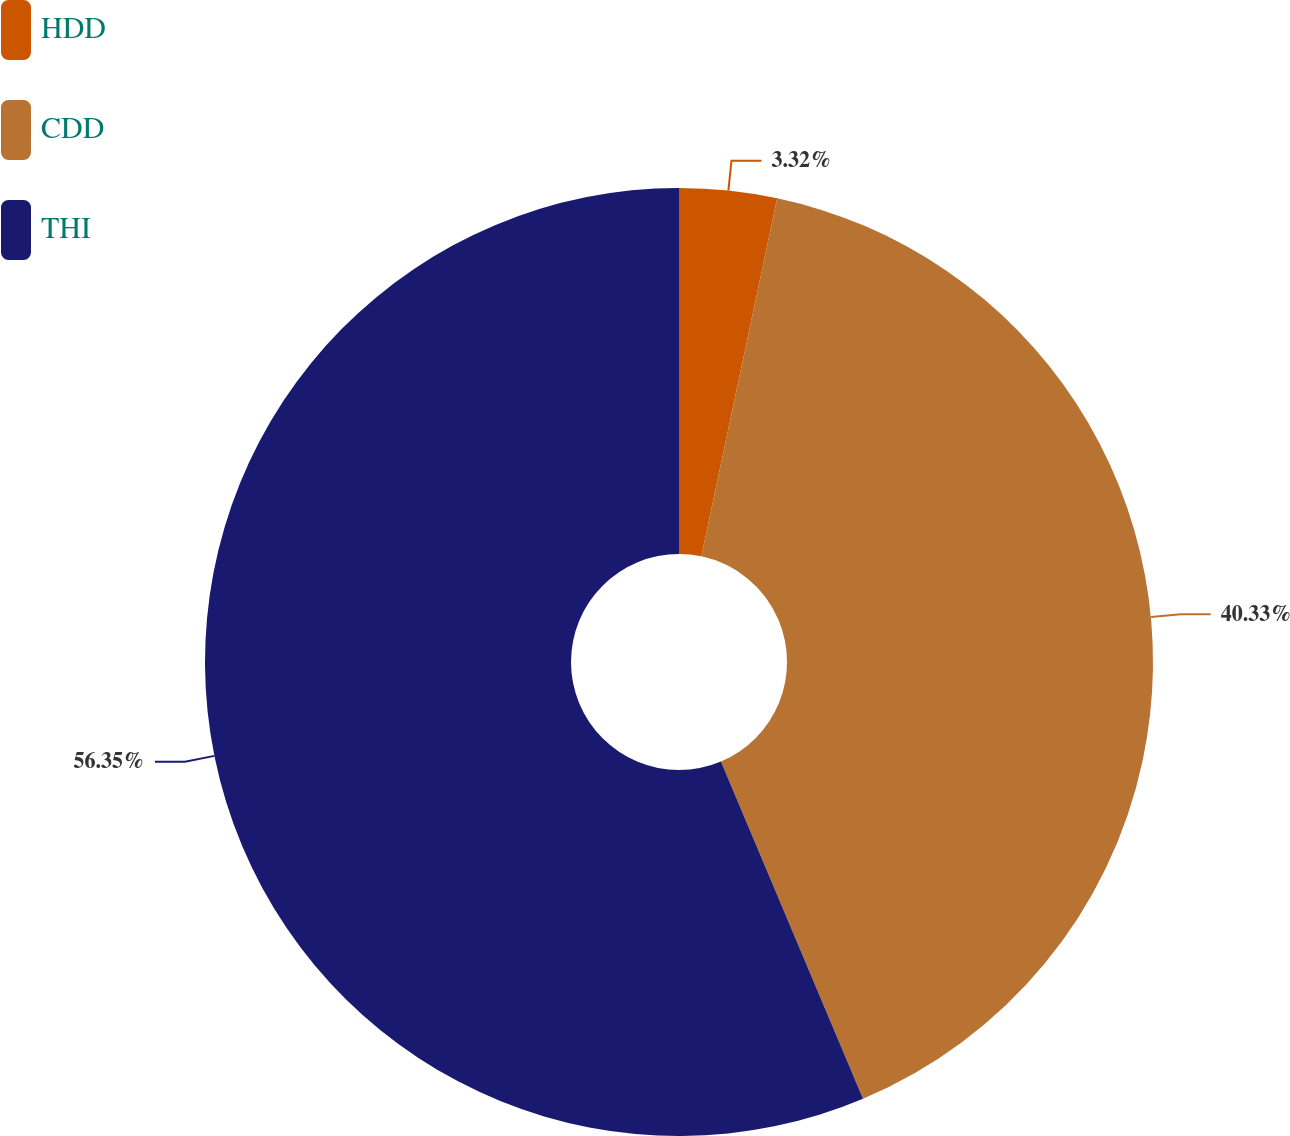Convert chart. <chart><loc_0><loc_0><loc_500><loc_500><pie_chart><fcel>HDD<fcel>CDD<fcel>THI<nl><fcel>3.32%<fcel>40.33%<fcel>56.34%<nl></chart> 